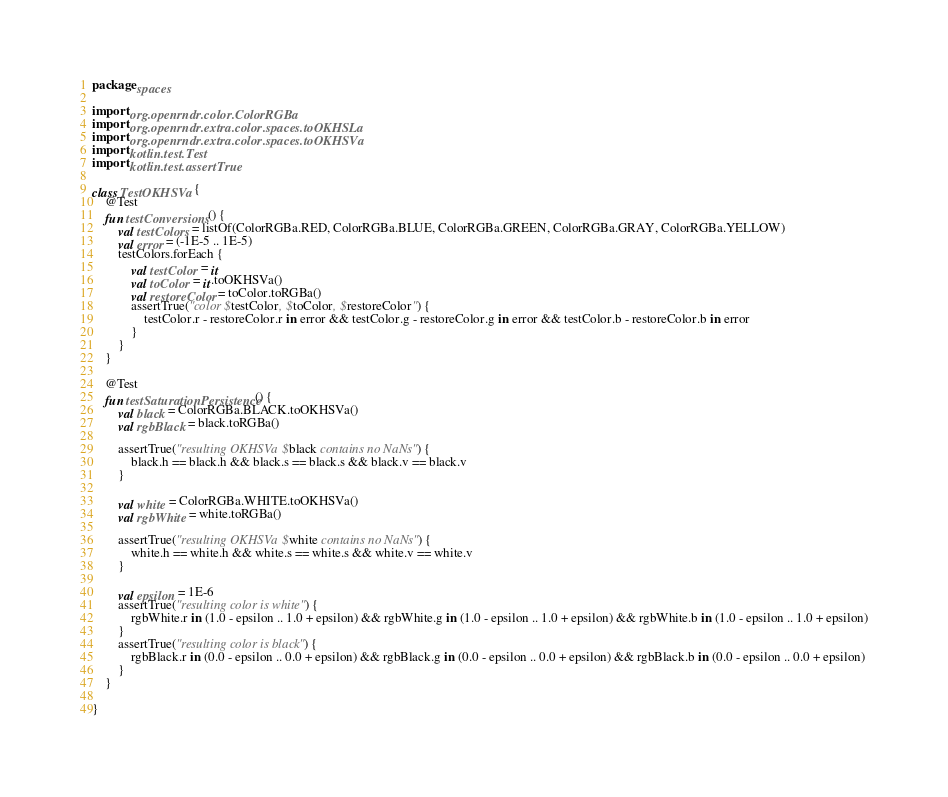Convert code to text. <code><loc_0><loc_0><loc_500><loc_500><_Kotlin_>package spaces

import org.openrndr.color.ColorRGBa
import org.openrndr.extra.color.spaces.toOKHSLa
import org.openrndr.extra.color.spaces.toOKHSVa
import kotlin.test.Test
import kotlin.test.assertTrue

class TestOKHSVa {
    @Test
    fun testConversions() {
        val testColors = listOf(ColorRGBa.RED, ColorRGBa.BLUE, ColorRGBa.GREEN, ColorRGBa.GRAY, ColorRGBa.YELLOW)
        val error = (-1E-5 .. 1E-5)
        testColors.forEach {
            val testColor = it
            val toColor = it.toOKHSVa()
            val restoreColor = toColor.toRGBa()
            assertTrue("color $testColor, $toColor, $restoreColor") {
                testColor.r - restoreColor.r in error && testColor.g - restoreColor.g in error && testColor.b - restoreColor.b in error
            }
        }
    }

    @Test
    fun testSaturationPersistence() {
        val black = ColorRGBa.BLACK.toOKHSVa()
        val rgbBlack = black.toRGBa()

        assertTrue("resulting OKHSVa $black contains no NaNs") {
            black.h == black.h && black.s == black.s && black.v == black.v
        }

        val white = ColorRGBa.WHITE.toOKHSVa()
        val rgbWhite = white.toRGBa()

        assertTrue("resulting OKHSVa $white contains no NaNs") {
            white.h == white.h && white.s == white.s && white.v == white.v
        }

        val epsilon = 1E-6
        assertTrue("resulting color is white") {
            rgbWhite.r in (1.0 - epsilon .. 1.0 + epsilon) && rgbWhite.g in (1.0 - epsilon .. 1.0 + epsilon) && rgbWhite.b in (1.0 - epsilon .. 1.0 + epsilon)
        }
        assertTrue("resulting color is black") {
            rgbBlack.r in (0.0 - epsilon .. 0.0 + epsilon) && rgbBlack.g in (0.0 - epsilon .. 0.0 + epsilon) && rgbBlack.b in (0.0 - epsilon .. 0.0 + epsilon)
        }
    }

}</code> 